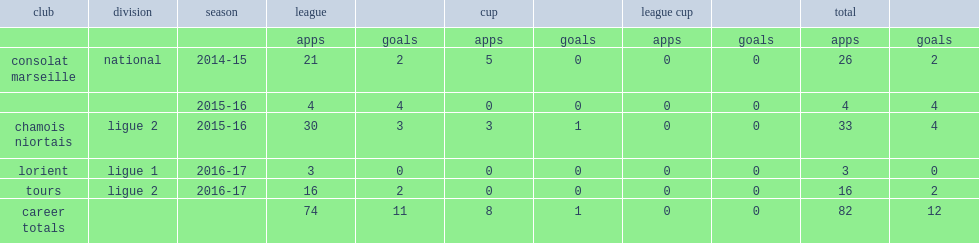Which club did faiz selemani join in national division ahead of the 2014-15 season? Consolat marseille. 